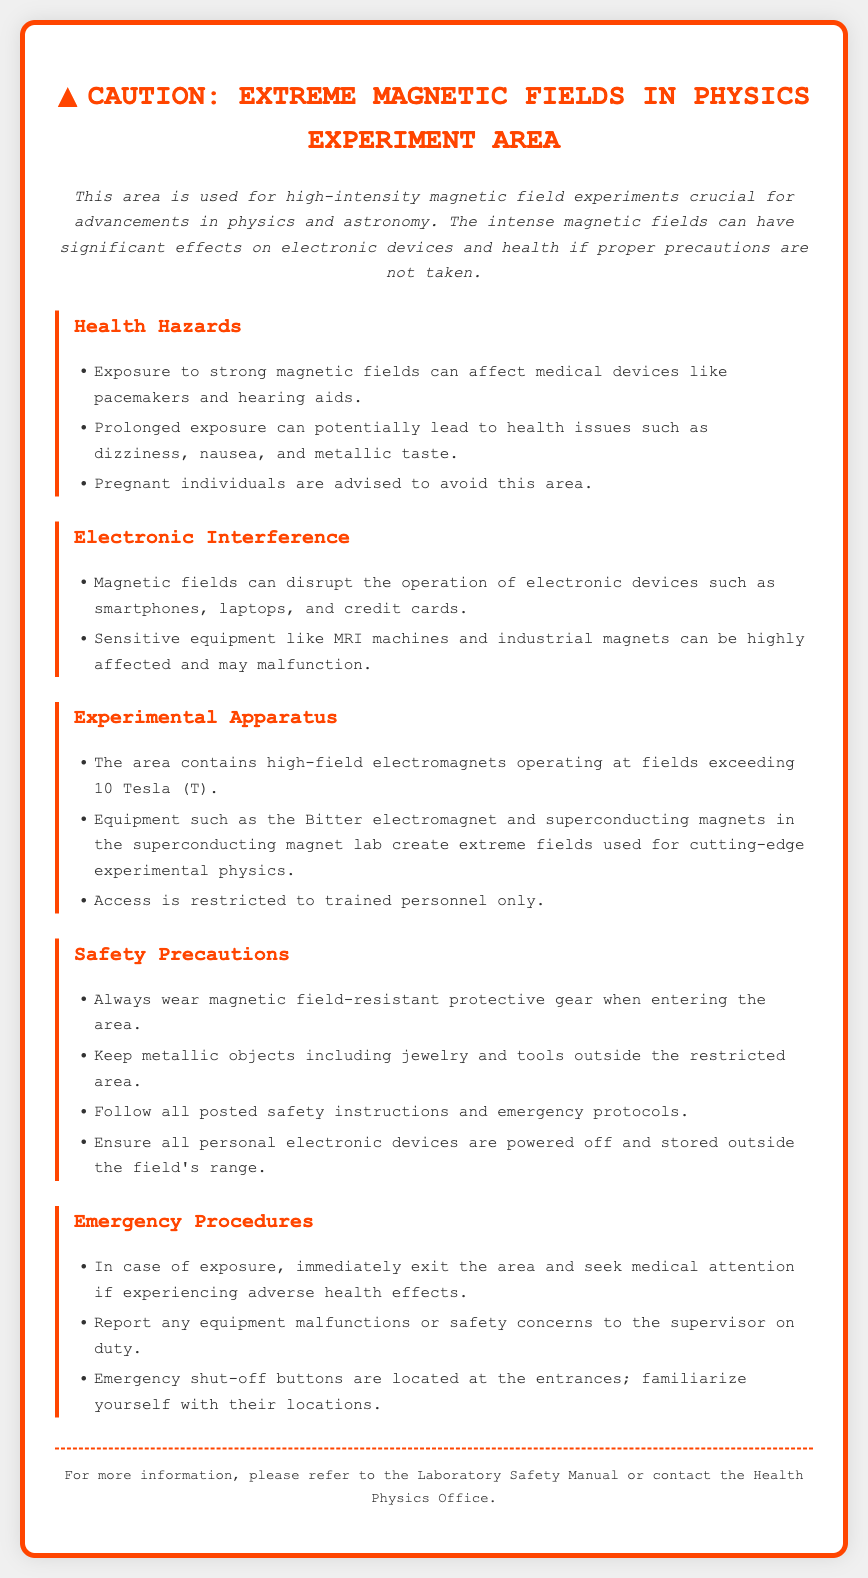What is the title of the warning label? The title is explicitly stated at the top of the document.
Answer: Caution: Extreme Magnetic Fields in Physics Experiment Area What intensity do the high-field electromagnets exceed? This information is mentioned in the section detailing the Experimental Apparatus.
Answer: 10 Tesla What are the advised precautions for pregnant individuals? This is found in the Health Hazards section advising who should avoid the area.
Answer: Avoid this area What should you do in case of exposure? The Emergency Procedures section outlines the actions to take after exposure.
Answer: Exit the area and seek medical attention What type of protective gear should be worn? The Safety Precautions section specifies the type of gear required.
Answer: Magnetic field-resistant protective gear Which devices can be disrupted by magnetic fields? The Electronic Interference section lists these devices.
Answer: Smartphones, laptops, and credit cards Who is allowed access to the experimental area? The Experimental Apparatus section specifies the access restriction.
Answer: Trained personnel only What type of equipment is mentioned in the Experimental Apparatus section? The section lists specific examples of equipment used in experiments.
Answer: Bitter electromagnet and superconducting magnets What should be done with personal electronic devices before entering? The Safety Precautions section highlights the care required regarding devices.
Answer: Powered off and stored outside the field's range 